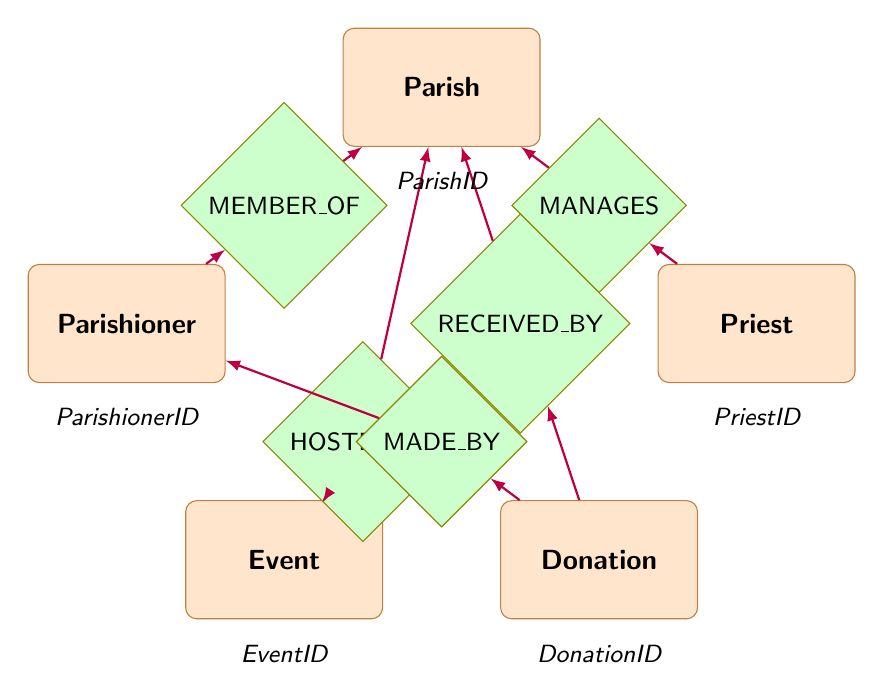What are the entities represented in the diagram? The diagram has five entities: Parish, Parishioner, Priest, Event, and Donation. These are visible as labeled rectangles in the diagram.
Answer: Parish, Parishioner, Priest, Event, Donation How many relationships are shown in the diagram? The diagram displays five relationships connecting the entities. Each relationship is represented as a diamond shape connecting two entities.
Answer: Five Which priest manages the parish? The relationship indicated by the "MANAGES" diamond shows that the Priest entity is connected to the Parish entity, implying a priest's management. Specific names are not stated, only the relationship is represented.
Answer: Priest What is the relationship between a parishioner and a parish? The "MEMBER_OF" relationship shows that each Parishioner is associated with a specific Parish, indicating membership through a direct connection in the diagram.
Answer: MEMBER_OF What type of events are hosted at the parish? The relationship labeled "HOSTED_BY" connects the Event entity to the Parish entity, indicating that events taking place are hosted by a parish.
Answer: HOSTED_BY How are donations linked to parishioners? The "MADE_BY" relationship connects the Donation entity to the Parishioner entity, which signifies that donations are made by parishioners as represented by arrows in the diagram.
Answer: MADE_BY Which entity receives donations? The "RECEIVED_BY" relationship connects the Donation entity to the Parish entity, indicating that donations are directed to the parish.
Answer: RECEIVED_BY What attributes are associated with the Parish entity? The Parish entity includes attributes such as ParishID, Name, Location, and ContactInfo as noted below the parish rectangle in the diagram.
Answer: ParishID, Name, Location, ContactInfo What is the purpose of the Event entity in the diagram? The Event entity serves to represent community gatherings or activities as indicated by its connections to the Parish and the relationship it has with the hosting parish.
Answer: Community activities 